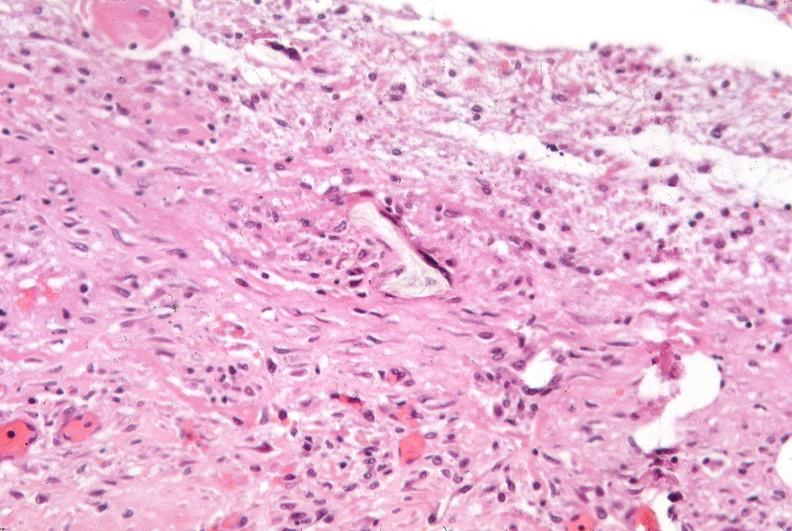where is this?
Answer the question using a single word or phrase. Lung 